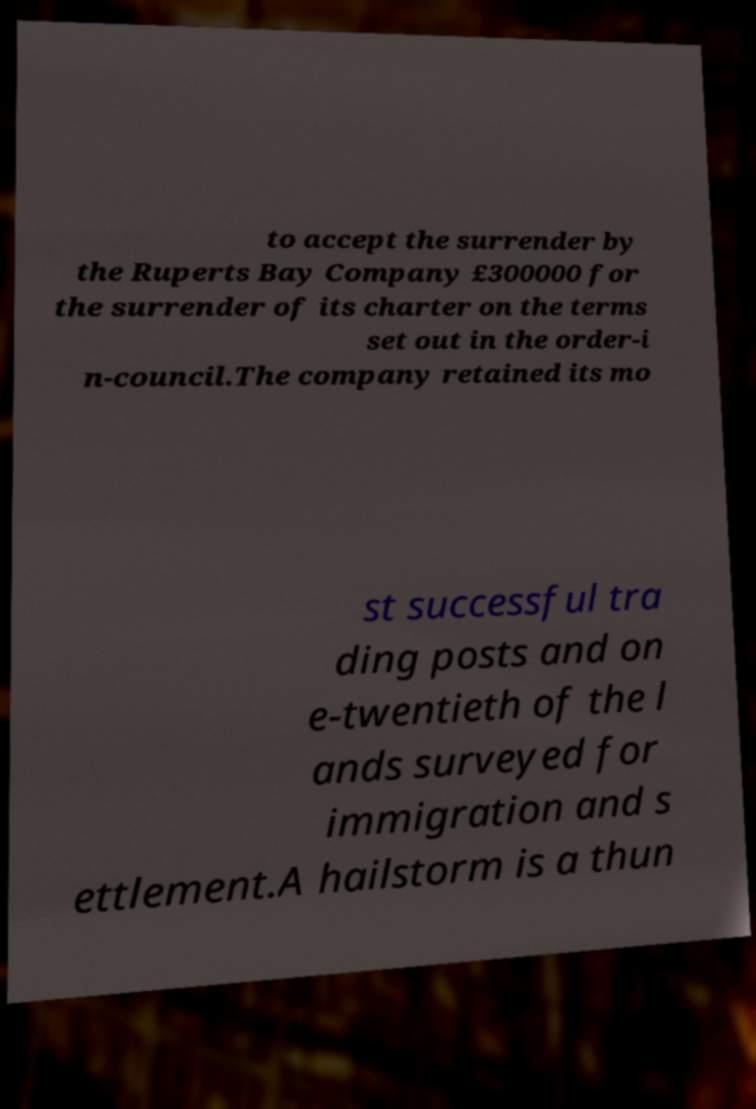Please identify and transcribe the text found in this image. to accept the surrender by the Ruperts Bay Company £300000 for the surrender of its charter on the terms set out in the order-i n-council.The company retained its mo st successful tra ding posts and on e-twentieth of the l ands surveyed for immigration and s ettlement.A hailstorm is a thun 